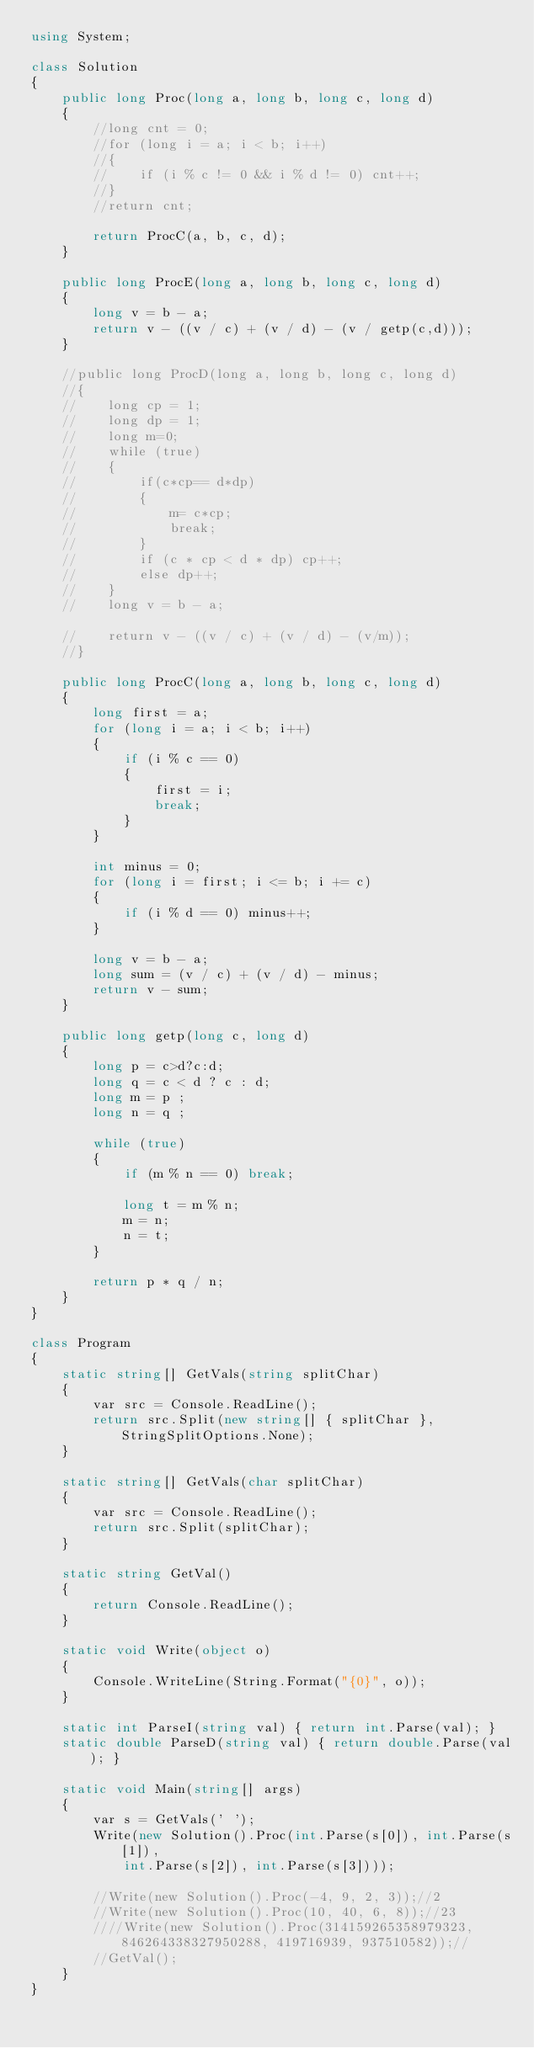<code> <loc_0><loc_0><loc_500><loc_500><_C#_>using System;

class Solution
{
    public long Proc(long a, long b, long c, long d)
    {
        //long cnt = 0;
        //for (long i = a; i < b; i++)
        //{
        //    if (i % c != 0 && i % d != 0) cnt++;
        //}
        //return cnt;

        return ProcC(a, b, c, d);
    }

    public long ProcE(long a, long b, long c, long d)
    {
        long v = b - a;
        return v - ((v / c) + (v / d) - (v / getp(c,d)));
    }

    //public long ProcD(long a, long b, long c, long d)
    //{
    //    long cp = 1;
    //    long dp = 1;
    //    long m=0;
    //    while (true)
    //    {
    //        if(c*cp== d*dp)
    //        {
    //            m= c*cp;
    //            break;
    //        }
    //        if (c * cp < d * dp) cp++;
    //        else dp++;
    //    }
    //    long v = b - a;
        
    //    return v - ((v / c) + (v / d) - (v/m));
    //}

    public long ProcC(long a, long b, long c, long d)
    {
        long first = a;
        for (long i = a; i < b; i++)
        {
            if (i % c == 0)
            {
                first = i;
                break;
            }
        }

        int minus = 0;
        for (long i = first; i <= b; i += c)
        {
            if (i % d == 0) minus++;
        }

        long v = b - a;
        long sum = (v / c) + (v / d) - minus;
        return v - sum;
    }

    public long getp(long c, long d)
    {
        long p = c>d?c:d;
        long q = c < d ? c : d;
        long m = p ;
        long n = q ;

        while (true)
        {
            if (m % n == 0) break;

            long t = m % n;
            m = n;
            n = t;
        }

        return p * q / n;
    }
}

class Program
{
    static string[] GetVals(string splitChar)
    {
        var src = Console.ReadLine();
        return src.Split(new string[] { splitChar }, StringSplitOptions.None);
    }

    static string[] GetVals(char splitChar)
    {
        var src = Console.ReadLine();
        return src.Split(splitChar);
    }

    static string GetVal()
    {
        return Console.ReadLine();
    }

    static void Write(object o)
    {
        Console.WriteLine(String.Format("{0}", o));
    }

    static int ParseI(string val) { return int.Parse(val); }
    static double ParseD(string val) { return double.Parse(val); }

    static void Main(string[] args)
    {
        var s = GetVals(' ');
        Write(new Solution().Proc(int.Parse(s[0]), int.Parse(s[1]),
            int.Parse(s[2]), int.Parse(s[3])));

        //Write(new Solution().Proc(-4, 9, 2, 3));//2
        //Write(new Solution().Proc(10, 40, 6, 8));//23
        ////Write(new Solution().Proc(314159265358979323, 846264338327950288, 419716939, 937510582));//
        //GetVal();
    }
}</code> 